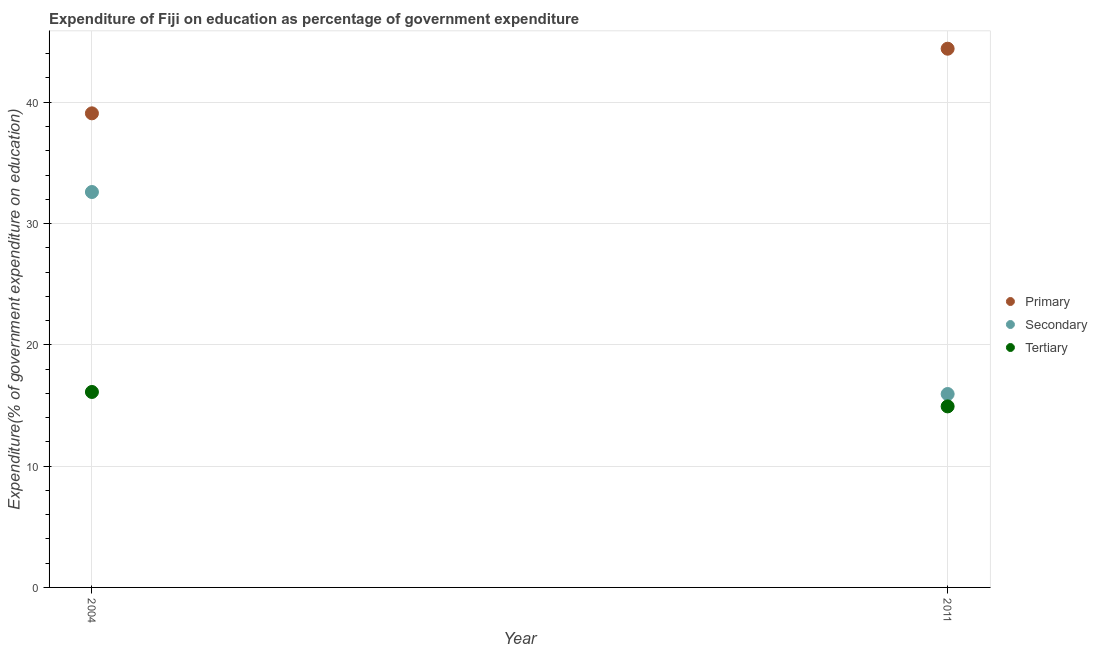What is the expenditure on tertiary education in 2011?
Provide a short and direct response. 14.92. Across all years, what is the maximum expenditure on secondary education?
Offer a very short reply. 32.6. Across all years, what is the minimum expenditure on primary education?
Your answer should be very brief. 39.08. In which year was the expenditure on tertiary education maximum?
Offer a very short reply. 2004. What is the total expenditure on tertiary education in the graph?
Make the answer very short. 31.04. What is the difference between the expenditure on primary education in 2004 and that in 2011?
Keep it short and to the point. -5.33. What is the difference between the expenditure on primary education in 2011 and the expenditure on secondary education in 2004?
Provide a succinct answer. 11.81. What is the average expenditure on tertiary education per year?
Ensure brevity in your answer.  15.52. In the year 2011, what is the difference between the expenditure on tertiary education and expenditure on secondary education?
Give a very brief answer. -1.02. What is the ratio of the expenditure on tertiary education in 2004 to that in 2011?
Your response must be concise. 1.08. Is the expenditure on primary education in 2004 less than that in 2011?
Your answer should be compact. Yes. Is the expenditure on secondary education strictly less than the expenditure on tertiary education over the years?
Ensure brevity in your answer.  No. Are the values on the major ticks of Y-axis written in scientific E-notation?
Provide a short and direct response. No. Does the graph contain any zero values?
Make the answer very short. No. Where does the legend appear in the graph?
Keep it short and to the point. Center right. How are the legend labels stacked?
Provide a short and direct response. Vertical. What is the title of the graph?
Your answer should be very brief. Expenditure of Fiji on education as percentage of government expenditure. What is the label or title of the Y-axis?
Provide a short and direct response. Expenditure(% of government expenditure on education). What is the Expenditure(% of government expenditure on education) in Primary in 2004?
Your response must be concise. 39.08. What is the Expenditure(% of government expenditure on education) in Secondary in 2004?
Make the answer very short. 32.6. What is the Expenditure(% of government expenditure on education) of Tertiary in 2004?
Your answer should be very brief. 16.11. What is the Expenditure(% of government expenditure on education) in Primary in 2011?
Your answer should be compact. 44.41. What is the Expenditure(% of government expenditure on education) of Secondary in 2011?
Your answer should be very brief. 15.94. What is the Expenditure(% of government expenditure on education) in Tertiary in 2011?
Offer a terse response. 14.92. Across all years, what is the maximum Expenditure(% of government expenditure on education) in Primary?
Offer a very short reply. 44.41. Across all years, what is the maximum Expenditure(% of government expenditure on education) in Secondary?
Offer a terse response. 32.6. Across all years, what is the maximum Expenditure(% of government expenditure on education) of Tertiary?
Keep it short and to the point. 16.11. Across all years, what is the minimum Expenditure(% of government expenditure on education) in Primary?
Keep it short and to the point. 39.08. Across all years, what is the minimum Expenditure(% of government expenditure on education) of Secondary?
Offer a very short reply. 15.94. Across all years, what is the minimum Expenditure(% of government expenditure on education) of Tertiary?
Offer a very short reply. 14.92. What is the total Expenditure(% of government expenditure on education) in Primary in the graph?
Offer a terse response. 83.5. What is the total Expenditure(% of government expenditure on education) in Secondary in the graph?
Your answer should be very brief. 48.54. What is the total Expenditure(% of government expenditure on education) in Tertiary in the graph?
Your response must be concise. 31.04. What is the difference between the Expenditure(% of government expenditure on education) in Primary in 2004 and that in 2011?
Make the answer very short. -5.33. What is the difference between the Expenditure(% of government expenditure on education) in Secondary in 2004 and that in 2011?
Your answer should be very brief. 16.65. What is the difference between the Expenditure(% of government expenditure on education) of Tertiary in 2004 and that in 2011?
Make the answer very short. 1.19. What is the difference between the Expenditure(% of government expenditure on education) of Primary in 2004 and the Expenditure(% of government expenditure on education) of Secondary in 2011?
Keep it short and to the point. 23.14. What is the difference between the Expenditure(% of government expenditure on education) of Primary in 2004 and the Expenditure(% of government expenditure on education) of Tertiary in 2011?
Offer a very short reply. 24.16. What is the difference between the Expenditure(% of government expenditure on education) of Secondary in 2004 and the Expenditure(% of government expenditure on education) of Tertiary in 2011?
Provide a short and direct response. 17.67. What is the average Expenditure(% of government expenditure on education) of Primary per year?
Give a very brief answer. 41.75. What is the average Expenditure(% of government expenditure on education) in Secondary per year?
Offer a terse response. 24.27. What is the average Expenditure(% of government expenditure on education) of Tertiary per year?
Offer a very short reply. 15.52. In the year 2004, what is the difference between the Expenditure(% of government expenditure on education) in Primary and Expenditure(% of government expenditure on education) in Secondary?
Give a very brief answer. 6.49. In the year 2004, what is the difference between the Expenditure(% of government expenditure on education) of Primary and Expenditure(% of government expenditure on education) of Tertiary?
Make the answer very short. 22.97. In the year 2004, what is the difference between the Expenditure(% of government expenditure on education) of Secondary and Expenditure(% of government expenditure on education) of Tertiary?
Your response must be concise. 16.48. In the year 2011, what is the difference between the Expenditure(% of government expenditure on education) of Primary and Expenditure(% of government expenditure on education) of Secondary?
Offer a terse response. 28.47. In the year 2011, what is the difference between the Expenditure(% of government expenditure on education) of Primary and Expenditure(% of government expenditure on education) of Tertiary?
Your answer should be very brief. 29.49. In the year 2011, what is the difference between the Expenditure(% of government expenditure on education) in Secondary and Expenditure(% of government expenditure on education) in Tertiary?
Ensure brevity in your answer.  1.02. What is the ratio of the Expenditure(% of government expenditure on education) of Secondary in 2004 to that in 2011?
Ensure brevity in your answer.  2.04. What is the ratio of the Expenditure(% of government expenditure on education) of Tertiary in 2004 to that in 2011?
Offer a very short reply. 1.08. What is the difference between the highest and the second highest Expenditure(% of government expenditure on education) of Primary?
Offer a very short reply. 5.33. What is the difference between the highest and the second highest Expenditure(% of government expenditure on education) in Secondary?
Provide a short and direct response. 16.65. What is the difference between the highest and the second highest Expenditure(% of government expenditure on education) of Tertiary?
Make the answer very short. 1.19. What is the difference between the highest and the lowest Expenditure(% of government expenditure on education) of Primary?
Offer a very short reply. 5.33. What is the difference between the highest and the lowest Expenditure(% of government expenditure on education) in Secondary?
Ensure brevity in your answer.  16.65. What is the difference between the highest and the lowest Expenditure(% of government expenditure on education) of Tertiary?
Provide a short and direct response. 1.19. 